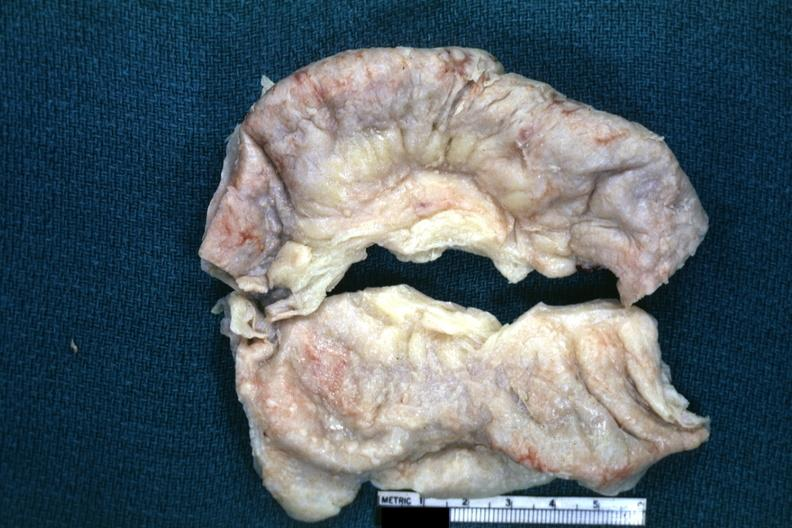s abdomen present?
Answer the question using a single word or phrase. Yes 